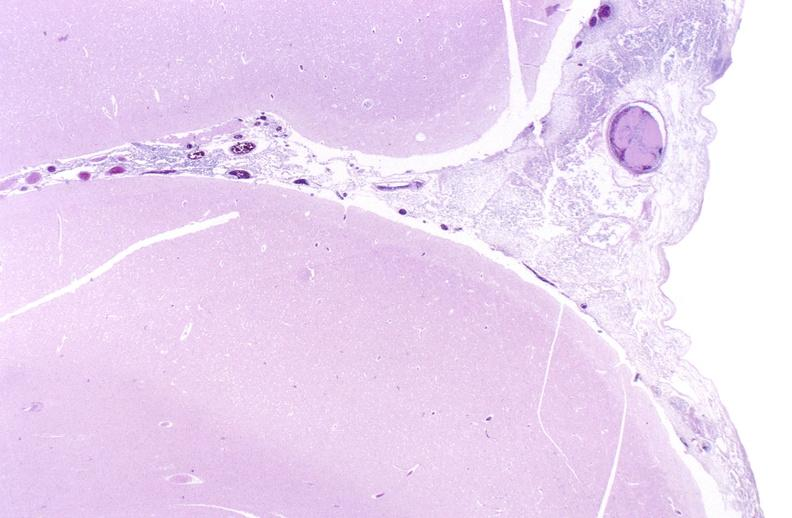s nervous present?
Answer the question using a single word or phrase. Yes 